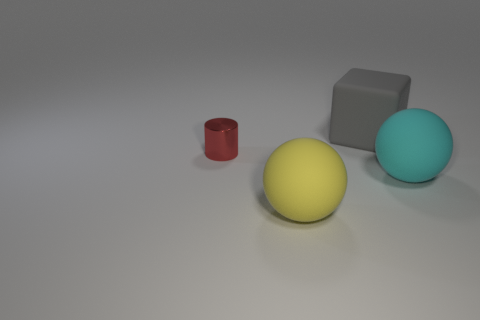Can you describe the colors and shapes present in the image? Certainly! The image features three distinct objects, each with a unique color and shape. There's a red cylinder, a yellow sphere, which appears to have a matte texture, and a gray cube. They are all placed against a neutral background, providing a clear view of each object's color and geometry. 